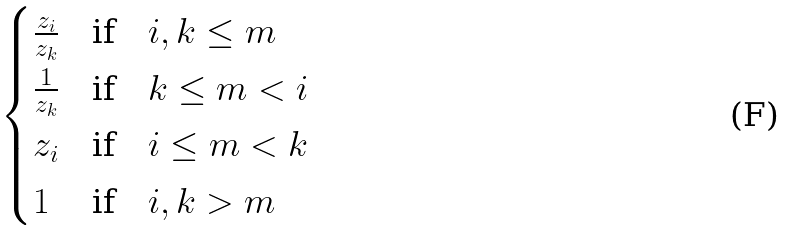Convert formula to latex. <formula><loc_0><loc_0><loc_500><loc_500>\begin{cases} \frac { z _ { i } } { z _ { k } } & \text {if} \quad i , k \leq m \\ \frac { 1 } { z _ { k } } & \text {if} \quad k \leq m < i \\ z _ { i } & \text {if} \quad i \leq m < k \\ 1 & \text {if} \quad i , k > m \end{cases}</formula> 